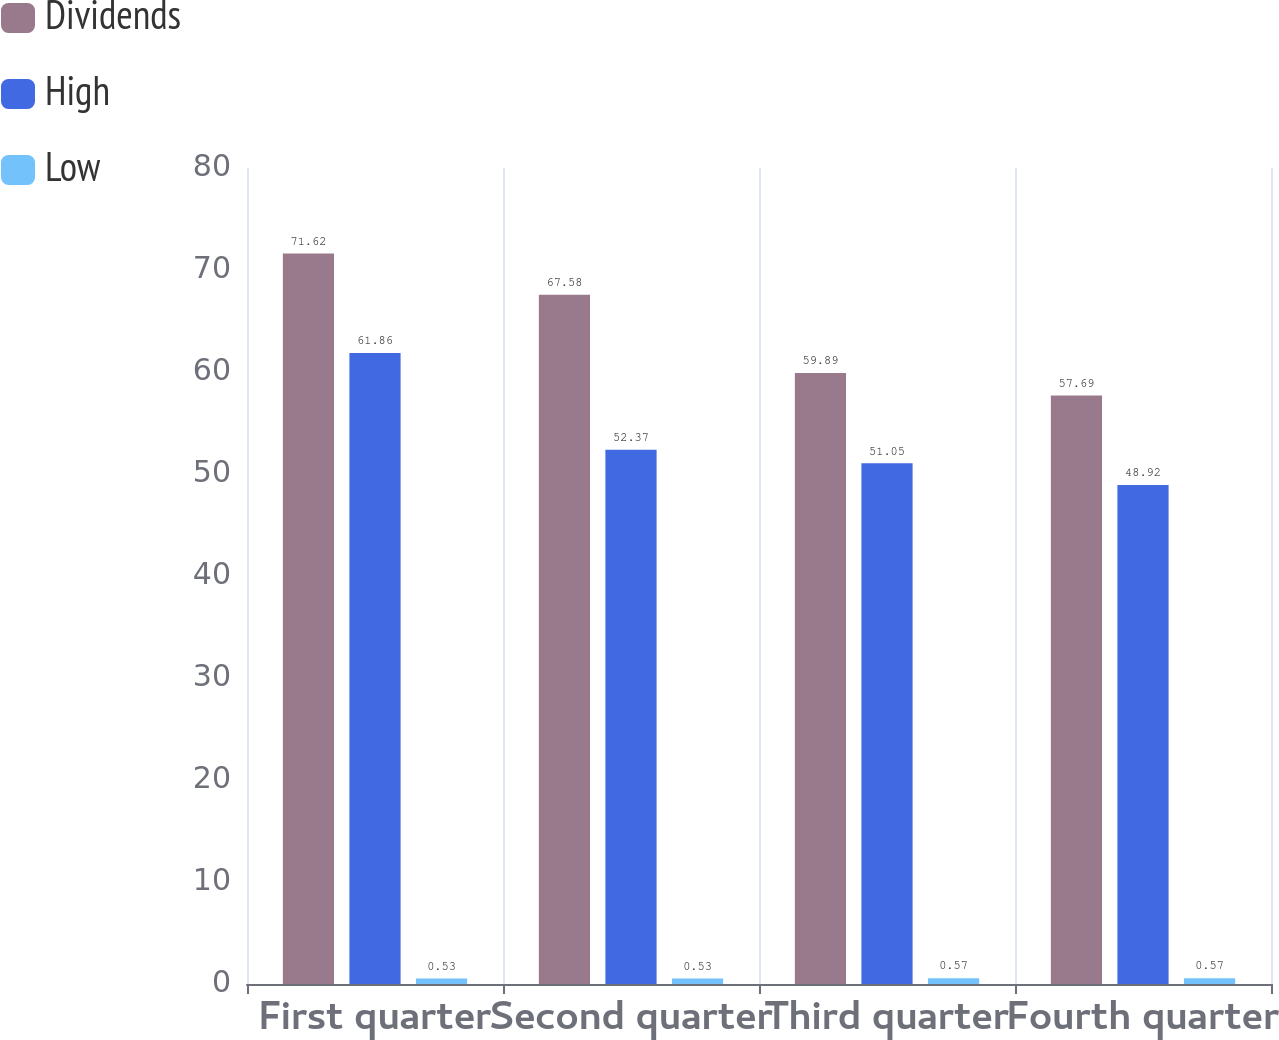Convert chart. <chart><loc_0><loc_0><loc_500><loc_500><stacked_bar_chart><ecel><fcel>First quarter<fcel>Second quarter<fcel>Third quarter<fcel>Fourth quarter<nl><fcel>Dividends<fcel>71.62<fcel>67.58<fcel>59.89<fcel>57.69<nl><fcel>High<fcel>61.86<fcel>52.37<fcel>51.05<fcel>48.92<nl><fcel>Low<fcel>0.53<fcel>0.53<fcel>0.57<fcel>0.57<nl></chart> 